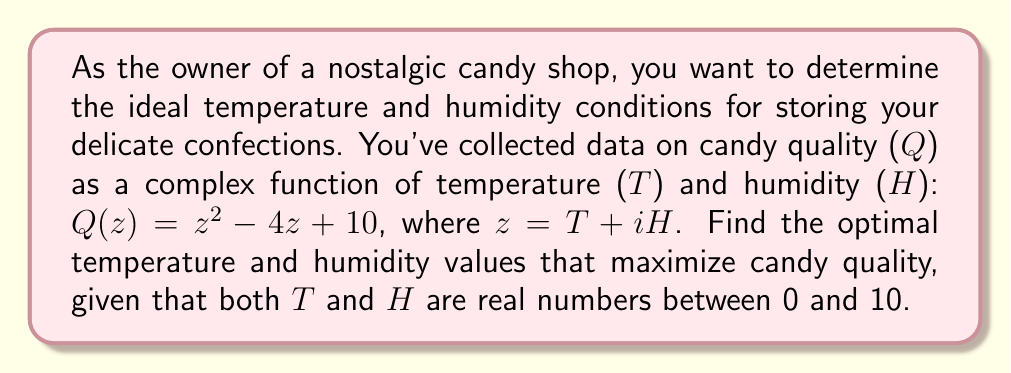Give your solution to this math problem. To solve this problem, we'll use complex analysis methods:

1) The quality function $Q(z) = z^2 - 4z + 10$ is analytic everywhere in the complex plane.

2) To find the maximum quality, we need to find the critical points of $Q(z)$. These occur where the derivative $Q'(z) = 0$.

3) The derivative of $Q(z)$ is:
   $Q'(z) = 2z - 4$

4) Setting $Q'(z) = 0$:
   $2z - 4 = 0$
   $2z = 4$
   $z = 2$

5) This critical point $z = 2$ represents the complex number where $T = 2$ and $H = 0$.

6) To confirm this is a maximum (not a minimum), we can check the second derivative:
   $Q''(z) = 2$, which is positive, confirming a local minimum for $-Q(z)$, thus a local maximum for $Q(z)$.

7) However, we need to check the boundaries of our domain (0 ≤ T ≤ 10, 0 ≤ H ≤ 10):

   At $z = 0$: $Q(0) = 10$
   At $z = 10$: $Q(10) = 110$
   At $z = 10i$: $Q(10i) = -90 + 10 = -80$

8) The maximum value at the boundaries occurs at $z = 10$, which corresponds to T = 10, H = 0.

9) Comparing $Q(2) = 2^2 - 4(2) + 10 = 10$ and $Q(10) = 110$, we see that the global maximum in our domain occurs at T = 10, H = 0.
Answer: The ideal conditions for candy storage are a temperature of 10 units and a humidity of 0 units, which maximizes the candy quality at 110 units. 